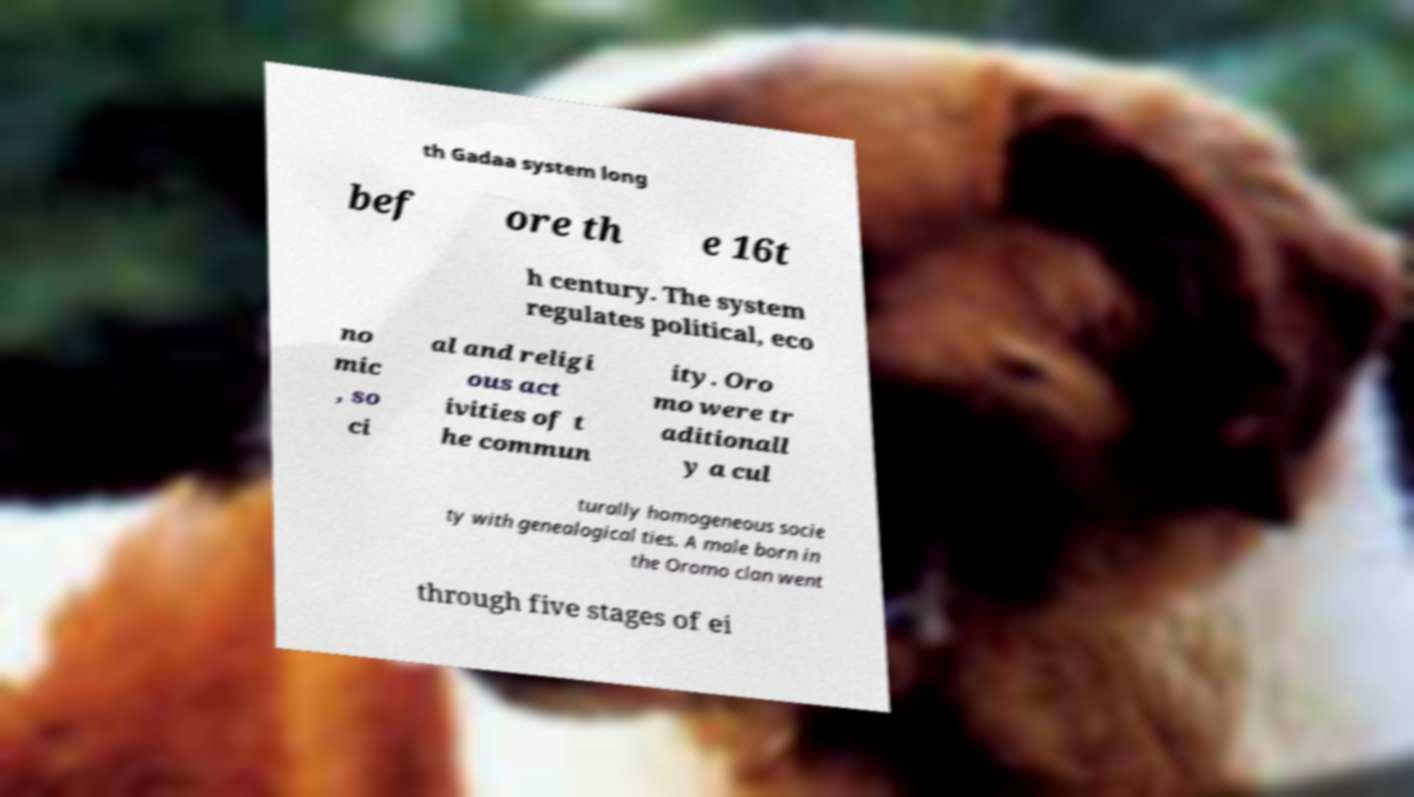For documentation purposes, I need the text within this image transcribed. Could you provide that? th Gadaa system long bef ore th e 16t h century. The system regulates political, eco no mic , so ci al and religi ous act ivities of t he commun ity. Oro mo were tr aditionall y a cul turally homogeneous socie ty with genealogical ties. A male born in the Oromo clan went through five stages of ei 